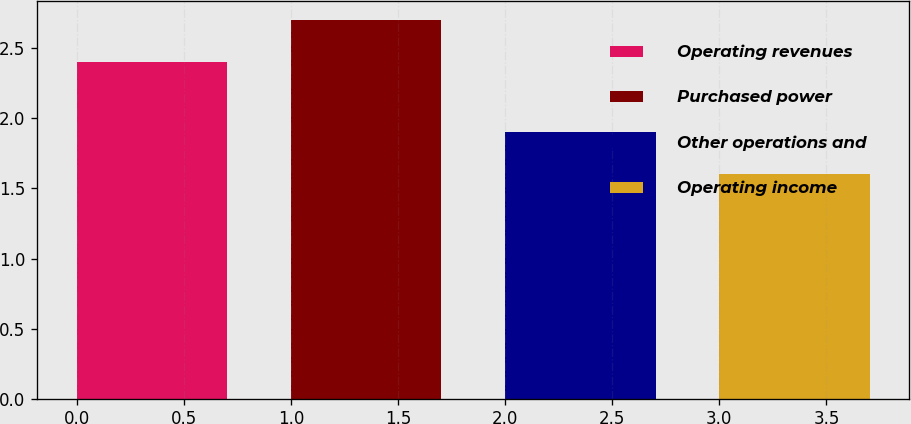<chart> <loc_0><loc_0><loc_500><loc_500><bar_chart><fcel>Operating revenues<fcel>Purchased power<fcel>Other operations and<fcel>Operating income<nl><fcel>2.4<fcel>2.7<fcel>1.9<fcel>1.6<nl></chart> 